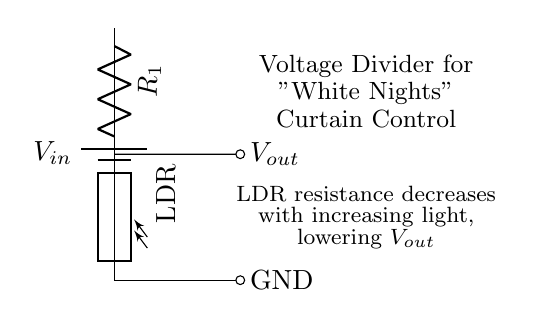What is the type of variable resistor shown in the circuit? The circuit shows a photoresistor, also known as an LDR, which changes resistance based on light intensity.
Answer: Photoresistor What happens to the output voltage when light intensity increases? As light intensity increases, the resistance of the LDR decreases, which lowers the output voltage according to the voltage divider principle.
Answer: It lowers What is the function of the battery in this circuit? The battery provides the input voltage needed to power the circuit, establishing a reference point for the voltage divider operation.
Answer: Power supply Which component is responsible for detecting light intensity in the circuit? The LDR is specifically designed for this purpose; it changes its resistance in response to the surrounding light levels.
Answer: LDR What role does the resistor R1 play in this circuit? Resistor R1, together with the LDR, forms a voltage divider, determining how the input voltage is divided between it and the LDR to set the output voltage.
Answer: Voltage division How does the output voltage relate to the input voltage in this circuit configuration? The output voltage is a fraction of the input voltage, determined by the ratio of the resistances of R1 and the LDR, according to the voltage divider formula.
Answer: Fraction of input voltage 